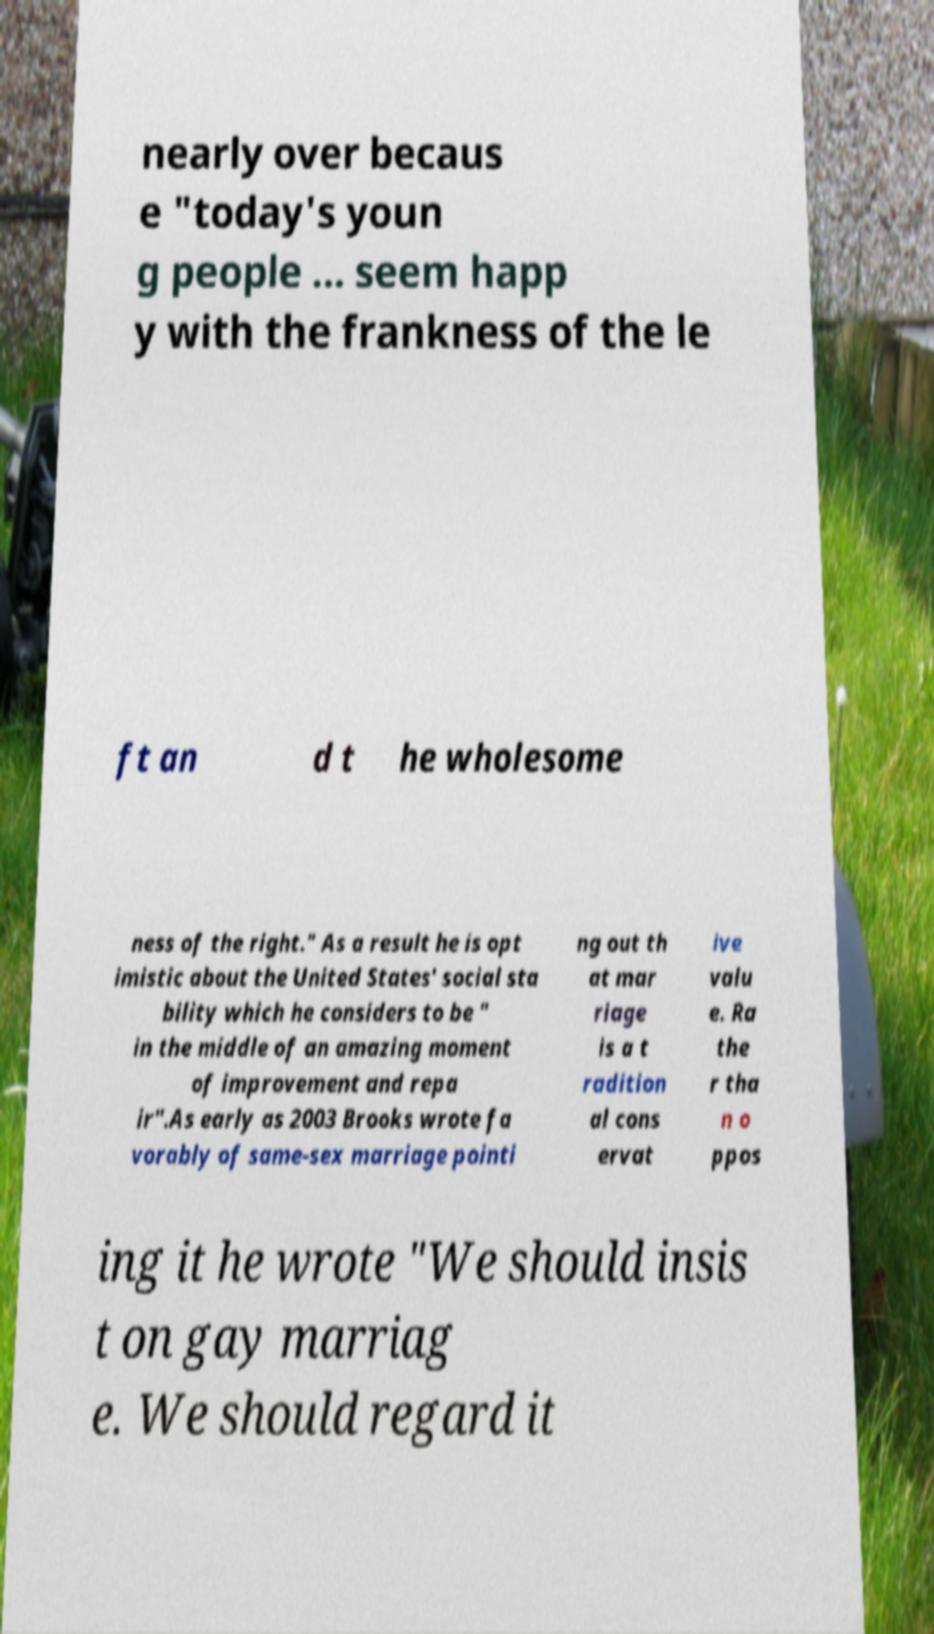Please read and relay the text visible in this image. What does it say? nearly over becaus e "today's youn g people ... seem happ y with the frankness of the le ft an d t he wholesome ness of the right." As a result he is opt imistic about the United States' social sta bility which he considers to be " in the middle of an amazing moment of improvement and repa ir".As early as 2003 Brooks wrote fa vorably of same-sex marriage pointi ng out th at mar riage is a t radition al cons ervat ive valu e. Ra the r tha n o ppos ing it he wrote "We should insis t on gay marriag e. We should regard it 